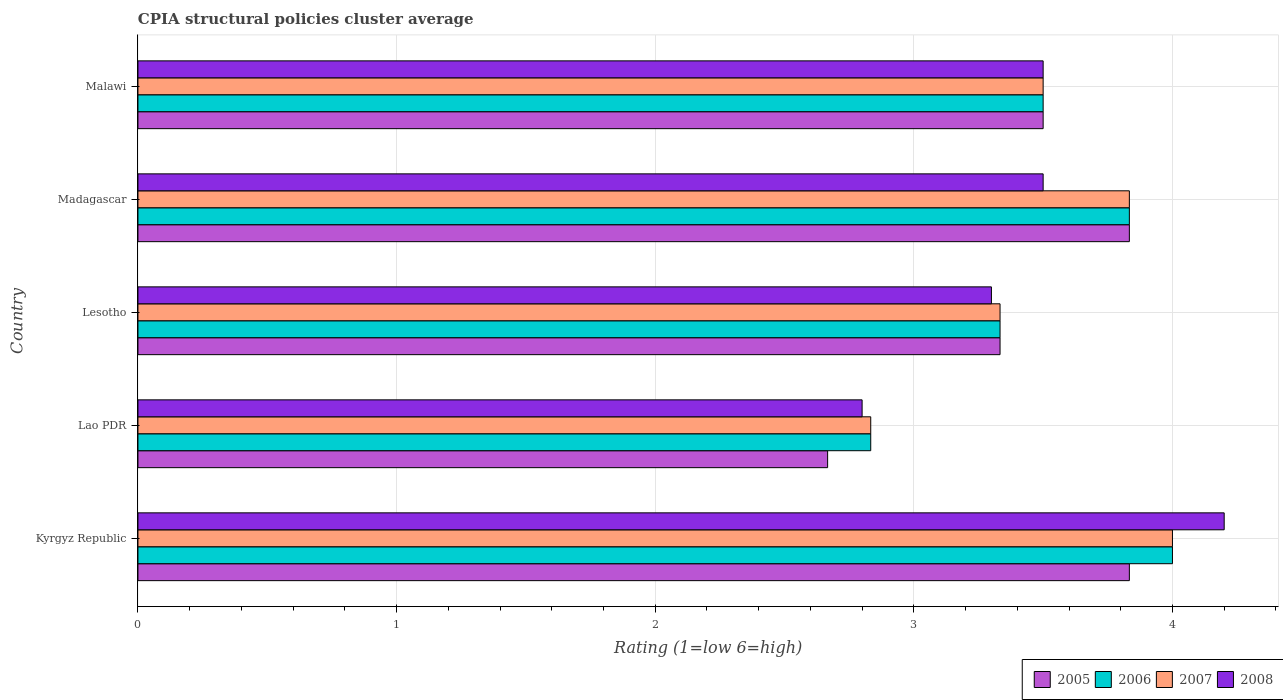How many bars are there on the 2nd tick from the top?
Provide a short and direct response. 4. How many bars are there on the 1st tick from the bottom?
Keep it short and to the point. 4. What is the label of the 5th group of bars from the top?
Your answer should be compact. Kyrgyz Republic. What is the CPIA rating in 2005 in Kyrgyz Republic?
Your answer should be compact. 3.83. Across all countries, what is the maximum CPIA rating in 2005?
Your answer should be very brief. 3.83. Across all countries, what is the minimum CPIA rating in 2006?
Keep it short and to the point. 2.83. In which country was the CPIA rating in 2005 maximum?
Your response must be concise. Kyrgyz Republic. In which country was the CPIA rating in 2005 minimum?
Give a very brief answer. Lao PDR. What is the total CPIA rating in 2008 in the graph?
Provide a short and direct response. 17.3. What is the difference between the CPIA rating in 2008 in Lesotho and that in Madagascar?
Ensure brevity in your answer.  -0.2. What is the difference between the CPIA rating in 2006 in Lao PDR and the CPIA rating in 2005 in Madagascar?
Offer a terse response. -1. What is the average CPIA rating in 2006 per country?
Offer a terse response. 3.5. What is the difference between the CPIA rating in 2008 and CPIA rating in 2007 in Madagascar?
Your answer should be very brief. -0.33. What is the ratio of the CPIA rating in 2008 in Madagascar to that in Malawi?
Provide a short and direct response. 1. Is the CPIA rating in 2005 in Lesotho less than that in Madagascar?
Ensure brevity in your answer.  Yes. Is the difference between the CPIA rating in 2008 in Kyrgyz Republic and Malawi greater than the difference between the CPIA rating in 2007 in Kyrgyz Republic and Malawi?
Make the answer very short. Yes. What is the difference between the highest and the second highest CPIA rating in 2007?
Make the answer very short. 0.17. What is the difference between the highest and the lowest CPIA rating in 2005?
Offer a terse response. 1.17. In how many countries, is the CPIA rating in 2005 greater than the average CPIA rating in 2005 taken over all countries?
Keep it short and to the point. 3. Is the sum of the CPIA rating in 2005 in Lao PDR and Madagascar greater than the maximum CPIA rating in 2006 across all countries?
Provide a succinct answer. Yes. Is it the case that in every country, the sum of the CPIA rating in 2007 and CPIA rating in 2006 is greater than the sum of CPIA rating in 2005 and CPIA rating in 2008?
Provide a short and direct response. No. What does the 4th bar from the top in Kyrgyz Republic represents?
Give a very brief answer. 2005. What does the 1st bar from the bottom in Kyrgyz Republic represents?
Your answer should be very brief. 2005. How many bars are there?
Give a very brief answer. 20. Are all the bars in the graph horizontal?
Make the answer very short. Yes. Are the values on the major ticks of X-axis written in scientific E-notation?
Offer a terse response. No. Does the graph contain any zero values?
Make the answer very short. No. Does the graph contain grids?
Your answer should be compact. Yes. Where does the legend appear in the graph?
Keep it short and to the point. Bottom right. What is the title of the graph?
Keep it short and to the point. CPIA structural policies cluster average. Does "1964" appear as one of the legend labels in the graph?
Your answer should be very brief. No. What is the label or title of the X-axis?
Provide a short and direct response. Rating (1=low 6=high). What is the label or title of the Y-axis?
Provide a short and direct response. Country. What is the Rating (1=low 6=high) in 2005 in Kyrgyz Republic?
Provide a short and direct response. 3.83. What is the Rating (1=low 6=high) of 2008 in Kyrgyz Republic?
Provide a succinct answer. 4.2. What is the Rating (1=low 6=high) in 2005 in Lao PDR?
Ensure brevity in your answer.  2.67. What is the Rating (1=low 6=high) in 2006 in Lao PDR?
Your answer should be compact. 2.83. What is the Rating (1=low 6=high) in 2007 in Lao PDR?
Ensure brevity in your answer.  2.83. What is the Rating (1=low 6=high) of 2008 in Lao PDR?
Your answer should be compact. 2.8. What is the Rating (1=low 6=high) in 2005 in Lesotho?
Offer a very short reply. 3.33. What is the Rating (1=low 6=high) in 2006 in Lesotho?
Give a very brief answer. 3.33. What is the Rating (1=low 6=high) of 2007 in Lesotho?
Make the answer very short. 3.33. What is the Rating (1=low 6=high) in 2008 in Lesotho?
Provide a succinct answer. 3.3. What is the Rating (1=low 6=high) of 2005 in Madagascar?
Give a very brief answer. 3.83. What is the Rating (1=low 6=high) in 2006 in Madagascar?
Make the answer very short. 3.83. What is the Rating (1=low 6=high) of 2007 in Madagascar?
Provide a short and direct response. 3.83. What is the Rating (1=low 6=high) of 2008 in Madagascar?
Provide a succinct answer. 3.5. Across all countries, what is the maximum Rating (1=low 6=high) in 2005?
Keep it short and to the point. 3.83. Across all countries, what is the maximum Rating (1=low 6=high) in 2006?
Give a very brief answer. 4. Across all countries, what is the minimum Rating (1=low 6=high) of 2005?
Ensure brevity in your answer.  2.67. Across all countries, what is the minimum Rating (1=low 6=high) in 2006?
Your answer should be very brief. 2.83. Across all countries, what is the minimum Rating (1=low 6=high) of 2007?
Ensure brevity in your answer.  2.83. Across all countries, what is the minimum Rating (1=low 6=high) in 2008?
Offer a terse response. 2.8. What is the total Rating (1=low 6=high) in 2005 in the graph?
Your response must be concise. 17.17. What is the total Rating (1=low 6=high) in 2007 in the graph?
Give a very brief answer. 17.5. What is the difference between the Rating (1=low 6=high) in 2006 in Kyrgyz Republic and that in Lao PDR?
Your answer should be compact. 1.17. What is the difference between the Rating (1=low 6=high) in 2007 in Kyrgyz Republic and that in Lao PDR?
Provide a succinct answer. 1.17. What is the difference between the Rating (1=low 6=high) in 2006 in Kyrgyz Republic and that in Lesotho?
Your response must be concise. 0.67. What is the difference between the Rating (1=low 6=high) of 2005 in Kyrgyz Republic and that in Madagascar?
Make the answer very short. 0. What is the difference between the Rating (1=low 6=high) in 2007 in Kyrgyz Republic and that in Madagascar?
Your answer should be compact. 0.17. What is the difference between the Rating (1=low 6=high) of 2008 in Kyrgyz Republic and that in Madagascar?
Ensure brevity in your answer.  0.7. What is the difference between the Rating (1=low 6=high) of 2005 in Kyrgyz Republic and that in Malawi?
Make the answer very short. 0.33. What is the difference between the Rating (1=low 6=high) in 2008 in Kyrgyz Republic and that in Malawi?
Provide a short and direct response. 0.7. What is the difference between the Rating (1=low 6=high) of 2005 in Lao PDR and that in Lesotho?
Keep it short and to the point. -0.67. What is the difference between the Rating (1=low 6=high) in 2006 in Lao PDR and that in Lesotho?
Your answer should be very brief. -0.5. What is the difference between the Rating (1=low 6=high) of 2008 in Lao PDR and that in Lesotho?
Offer a very short reply. -0.5. What is the difference between the Rating (1=low 6=high) in 2005 in Lao PDR and that in Madagascar?
Your response must be concise. -1.17. What is the difference between the Rating (1=low 6=high) of 2006 in Lao PDR and that in Madagascar?
Make the answer very short. -1. What is the difference between the Rating (1=low 6=high) of 2007 in Lao PDR and that in Madagascar?
Your response must be concise. -1. What is the difference between the Rating (1=low 6=high) in 2006 in Lao PDR and that in Malawi?
Provide a succinct answer. -0.67. What is the difference between the Rating (1=low 6=high) of 2005 in Lesotho and that in Madagascar?
Keep it short and to the point. -0.5. What is the difference between the Rating (1=low 6=high) of 2007 in Lesotho and that in Madagascar?
Keep it short and to the point. -0.5. What is the difference between the Rating (1=low 6=high) of 2008 in Lesotho and that in Madagascar?
Your answer should be very brief. -0.2. What is the difference between the Rating (1=low 6=high) in 2005 in Lesotho and that in Malawi?
Offer a very short reply. -0.17. What is the difference between the Rating (1=low 6=high) of 2006 in Lesotho and that in Malawi?
Ensure brevity in your answer.  -0.17. What is the difference between the Rating (1=low 6=high) in 2007 in Lesotho and that in Malawi?
Provide a short and direct response. -0.17. What is the difference between the Rating (1=low 6=high) in 2008 in Lesotho and that in Malawi?
Ensure brevity in your answer.  -0.2. What is the difference between the Rating (1=low 6=high) in 2005 in Madagascar and that in Malawi?
Make the answer very short. 0.33. What is the difference between the Rating (1=low 6=high) in 2008 in Madagascar and that in Malawi?
Your answer should be very brief. 0. What is the difference between the Rating (1=low 6=high) of 2005 in Kyrgyz Republic and the Rating (1=low 6=high) of 2007 in Lao PDR?
Keep it short and to the point. 1. What is the difference between the Rating (1=low 6=high) of 2006 in Kyrgyz Republic and the Rating (1=low 6=high) of 2007 in Lao PDR?
Your response must be concise. 1.17. What is the difference between the Rating (1=low 6=high) of 2006 in Kyrgyz Republic and the Rating (1=low 6=high) of 2008 in Lao PDR?
Your answer should be very brief. 1.2. What is the difference between the Rating (1=low 6=high) of 2007 in Kyrgyz Republic and the Rating (1=low 6=high) of 2008 in Lao PDR?
Give a very brief answer. 1.2. What is the difference between the Rating (1=low 6=high) of 2005 in Kyrgyz Republic and the Rating (1=low 6=high) of 2006 in Lesotho?
Ensure brevity in your answer.  0.5. What is the difference between the Rating (1=low 6=high) in 2005 in Kyrgyz Republic and the Rating (1=low 6=high) in 2008 in Lesotho?
Give a very brief answer. 0.53. What is the difference between the Rating (1=low 6=high) in 2006 in Kyrgyz Republic and the Rating (1=low 6=high) in 2007 in Lesotho?
Your answer should be very brief. 0.67. What is the difference between the Rating (1=low 6=high) of 2005 in Kyrgyz Republic and the Rating (1=low 6=high) of 2007 in Madagascar?
Offer a very short reply. 0. What is the difference between the Rating (1=low 6=high) of 2007 in Kyrgyz Republic and the Rating (1=low 6=high) of 2008 in Madagascar?
Ensure brevity in your answer.  0.5. What is the difference between the Rating (1=low 6=high) in 2005 in Kyrgyz Republic and the Rating (1=low 6=high) in 2006 in Malawi?
Your response must be concise. 0.33. What is the difference between the Rating (1=low 6=high) in 2005 in Kyrgyz Republic and the Rating (1=low 6=high) in 2007 in Malawi?
Give a very brief answer. 0.33. What is the difference between the Rating (1=low 6=high) in 2005 in Lao PDR and the Rating (1=low 6=high) in 2006 in Lesotho?
Give a very brief answer. -0.67. What is the difference between the Rating (1=low 6=high) in 2005 in Lao PDR and the Rating (1=low 6=high) in 2007 in Lesotho?
Give a very brief answer. -0.67. What is the difference between the Rating (1=low 6=high) in 2005 in Lao PDR and the Rating (1=low 6=high) in 2008 in Lesotho?
Your answer should be very brief. -0.63. What is the difference between the Rating (1=low 6=high) in 2006 in Lao PDR and the Rating (1=low 6=high) in 2008 in Lesotho?
Offer a terse response. -0.47. What is the difference between the Rating (1=low 6=high) in 2007 in Lao PDR and the Rating (1=low 6=high) in 2008 in Lesotho?
Offer a very short reply. -0.47. What is the difference between the Rating (1=low 6=high) of 2005 in Lao PDR and the Rating (1=low 6=high) of 2006 in Madagascar?
Offer a terse response. -1.17. What is the difference between the Rating (1=low 6=high) in 2005 in Lao PDR and the Rating (1=low 6=high) in 2007 in Madagascar?
Your answer should be very brief. -1.17. What is the difference between the Rating (1=low 6=high) of 2006 in Lao PDR and the Rating (1=low 6=high) of 2007 in Madagascar?
Your answer should be compact. -1. What is the difference between the Rating (1=low 6=high) of 2005 in Lao PDR and the Rating (1=low 6=high) of 2007 in Malawi?
Offer a terse response. -0.83. What is the difference between the Rating (1=low 6=high) of 2006 in Lao PDR and the Rating (1=low 6=high) of 2007 in Malawi?
Your response must be concise. -0.67. What is the difference between the Rating (1=low 6=high) in 2006 in Lao PDR and the Rating (1=low 6=high) in 2008 in Malawi?
Your answer should be compact. -0.67. What is the difference between the Rating (1=low 6=high) in 2005 in Lesotho and the Rating (1=low 6=high) in 2006 in Madagascar?
Your answer should be compact. -0.5. What is the difference between the Rating (1=low 6=high) in 2005 in Lesotho and the Rating (1=low 6=high) in 2007 in Madagascar?
Make the answer very short. -0.5. What is the difference between the Rating (1=low 6=high) of 2005 in Lesotho and the Rating (1=low 6=high) of 2008 in Madagascar?
Provide a succinct answer. -0.17. What is the difference between the Rating (1=low 6=high) in 2007 in Lesotho and the Rating (1=low 6=high) in 2008 in Madagascar?
Offer a terse response. -0.17. What is the difference between the Rating (1=low 6=high) in 2005 in Lesotho and the Rating (1=low 6=high) in 2007 in Malawi?
Provide a succinct answer. -0.17. What is the difference between the Rating (1=low 6=high) in 2005 in Lesotho and the Rating (1=low 6=high) in 2008 in Malawi?
Keep it short and to the point. -0.17. What is the difference between the Rating (1=low 6=high) in 2006 in Lesotho and the Rating (1=low 6=high) in 2007 in Malawi?
Offer a terse response. -0.17. What is the difference between the Rating (1=low 6=high) in 2005 in Madagascar and the Rating (1=low 6=high) in 2007 in Malawi?
Provide a succinct answer. 0.33. What is the difference between the Rating (1=low 6=high) in 2005 in Madagascar and the Rating (1=low 6=high) in 2008 in Malawi?
Offer a very short reply. 0.33. What is the difference between the Rating (1=low 6=high) of 2007 in Madagascar and the Rating (1=low 6=high) of 2008 in Malawi?
Your answer should be very brief. 0.33. What is the average Rating (1=low 6=high) in 2005 per country?
Offer a very short reply. 3.43. What is the average Rating (1=low 6=high) of 2006 per country?
Your answer should be compact. 3.5. What is the average Rating (1=low 6=high) of 2008 per country?
Your answer should be compact. 3.46. What is the difference between the Rating (1=low 6=high) in 2005 and Rating (1=low 6=high) in 2008 in Kyrgyz Republic?
Ensure brevity in your answer.  -0.37. What is the difference between the Rating (1=low 6=high) of 2006 and Rating (1=low 6=high) of 2007 in Kyrgyz Republic?
Offer a very short reply. 0. What is the difference between the Rating (1=low 6=high) of 2006 and Rating (1=low 6=high) of 2008 in Kyrgyz Republic?
Offer a very short reply. -0.2. What is the difference between the Rating (1=low 6=high) in 2005 and Rating (1=low 6=high) in 2006 in Lao PDR?
Provide a short and direct response. -0.17. What is the difference between the Rating (1=low 6=high) in 2005 and Rating (1=low 6=high) in 2007 in Lao PDR?
Make the answer very short. -0.17. What is the difference between the Rating (1=low 6=high) of 2005 and Rating (1=low 6=high) of 2008 in Lao PDR?
Provide a short and direct response. -0.13. What is the difference between the Rating (1=low 6=high) in 2006 and Rating (1=low 6=high) in 2007 in Lao PDR?
Your response must be concise. 0. What is the difference between the Rating (1=low 6=high) in 2006 and Rating (1=low 6=high) in 2008 in Lao PDR?
Provide a short and direct response. 0.03. What is the difference between the Rating (1=low 6=high) in 2006 and Rating (1=low 6=high) in 2007 in Lesotho?
Provide a short and direct response. 0. What is the difference between the Rating (1=low 6=high) of 2005 and Rating (1=low 6=high) of 2006 in Madagascar?
Offer a terse response. 0. What is the difference between the Rating (1=low 6=high) of 2006 and Rating (1=low 6=high) of 2008 in Madagascar?
Provide a succinct answer. 0.33. What is the difference between the Rating (1=low 6=high) of 2006 and Rating (1=low 6=high) of 2007 in Malawi?
Offer a very short reply. 0. What is the ratio of the Rating (1=low 6=high) in 2005 in Kyrgyz Republic to that in Lao PDR?
Ensure brevity in your answer.  1.44. What is the ratio of the Rating (1=low 6=high) of 2006 in Kyrgyz Republic to that in Lao PDR?
Offer a terse response. 1.41. What is the ratio of the Rating (1=low 6=high) in 2007 in Kyrgyz Republic to that in Lao PDR?
Your answer should be very brief. 1.41. What is the ratio of the Rating (1=low 6=high) in 2008 in Kyrgyz Republic to that in Lao PDR?
Give a very brief answer. 1.5. What is the ratio of the Rating (1=low 6=high) of 2005 in Kyrgyz Republic to that in Lesotho?
Offer a very short reply. 1.15. What is the ratio of the Rating (1=low 6=high) of 2006 in Kyrgyz Republic to that in Lesotho?
Make the answer very short. 1.2. What is the ratio of the Rating (1=low 6=high) in 2008 in Kyrgyz Republic to that in Lesotho?
Your answer should be very brief. 1.27. What is the ratio of the Rating (1=low 6=high) of 2006 in Kyrgyz Republic to that in Madagascar?
Your answer should be very brief. 1.04. What is the ratio of the Rating (1=low 6=high) in 2007 in Kyrgyz Republic to that in Madagascar?
Keep it short and to the point. 1.04. What is the ratio of the Rating (1=low 6=high) of 2008 in Kyrgyz Republic to that in Madagascar?
Give a very brief answer. 1.2. What is the ratio of the Rating (1=low 6=high) in 2005 in Kyrgyz Republic to that in Malawi?
Offer a very short reply. 1.1. What is the ratio of the Rating (1=low 6=high) of 2005 in Lao PDR to that in Lesotho?
Your response must be concise. 0.8. What is the ratio of the Rating (1=low 6=high) of 2008 in Lao PDR to that in Lesotho?
Ensure brevity in your answer.  0.85. What is the ratio of the Rating (1=low 6=high) in 2005 in Lao PDR to that in Madagascar?
Offer a terse response. 0.7. What is the ratio of the Rating (1=low 6=high) of 2006 in Lao PDR to that in Madagascar?
Make the answer very short. 0.74. What is the ratio of the Rating (1=low 6=high) of 2007 in Lao PDR to that in Madagascar?
Keep it short and to the point. 0.74. What is the ratio of the Rating (1=low 6=high) of 2008 in Lao PDR to that in Madagascar?
Your answer should be compact. 0.8. What is the ratio of the Rating (1=low 6=high) of 2005 in Lao PDR to that in Malawi?
Ensure brevity in your answer.  0.76. What is the ratio of the Rating (1=low 6=high) of 2006 in Lao PDR to that in Malawi?
Your answer should be compact. 0.81. What is the ratio of the Rating (1=low 6=high) of 2007 in Lao PDR to that in Malawi?
Provide a short and direct response. 0.81. What is the ratio of the Rating (1=low 6=high) in 2005 in Lesotho to that in Madagascar?
Offer a terse response. 0.87. What is the ratio of the Rating (1=low 6=high) of 2006 in Lesotho to that in Madagascar?
Provide a short and direct response. 0.87. What is the ratio of the Rating (1=low 6=high) of 2007 in Lesotho to that in Madagascar?
Keep it short and to the point. 0.87. What is the ratio of the Rating (1=low 6=high) of 2008 in Lesotho to that in Madagascar?
Provide a short and direct response. 0.94. What is the ratio of the Rating (1=low 6=high) of 2005 in Lesotho to that in Malawi?
Give a very brief answer. 0.95. What is the ratio of the Rating (1=low 6=high) in 2006 in Lesotho to that in Malawi?
Ensure brevity in your answer.  0.95. What is the ratio of the Rating (1=low 6=high) in 2008 in Lesotho to that in Malawi?
Offer a terse response. 0.94. What is the ratio of the Rating (1=low 6=high) of 2005 in Madagascar to that in Malawi?
Offer a terse response. 1.1. What is the ratio of the Rating (1=low 6=high) of 2006 in Madagascar to that in Malawi?
Provide a short and direct response. 1.1. What is the ratio of the Rating (1=low 6=high) of 2007 in Madagascar to that in Malawi?
Give a very brief answer. 1.1. What is the ratio of the Rating (1=low 6=high) in 2008 in Madagascar to that in Malawi?
Ensure brevity in your answer.  1. What is the difference between the highest and the second highest Rating (1=low 6=high) in 2005?
Ensure brevity in your answer.  0. What is the difference between the highest and the second highest Rating (1=low 6=high) in 2006?
Your response must be concise. 0.17. What is the difference between the highest and the second highest Rating (1=low 6=high) in 2007?
Give a very brief answer. 0.17. What is the difference between the highest and the second highest Rating (1=low 6=high) of 2008?
Your response must be concise. 0.7. What is the difference between the highest and the lowest Rating (1=low 6=high) in 2006?
Your answer should be very brief. 1.17. What is the difference between the highest and the lowest Rating (1=low 6=high) in 2007?
Your response must be concise. 1.17. 